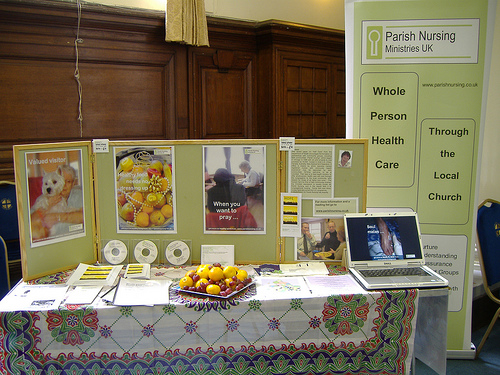<image>
Is there a fruits on the table? Yes. Looking at the image, I can see the fruits is positioned on top of the table, with the table providing support. 